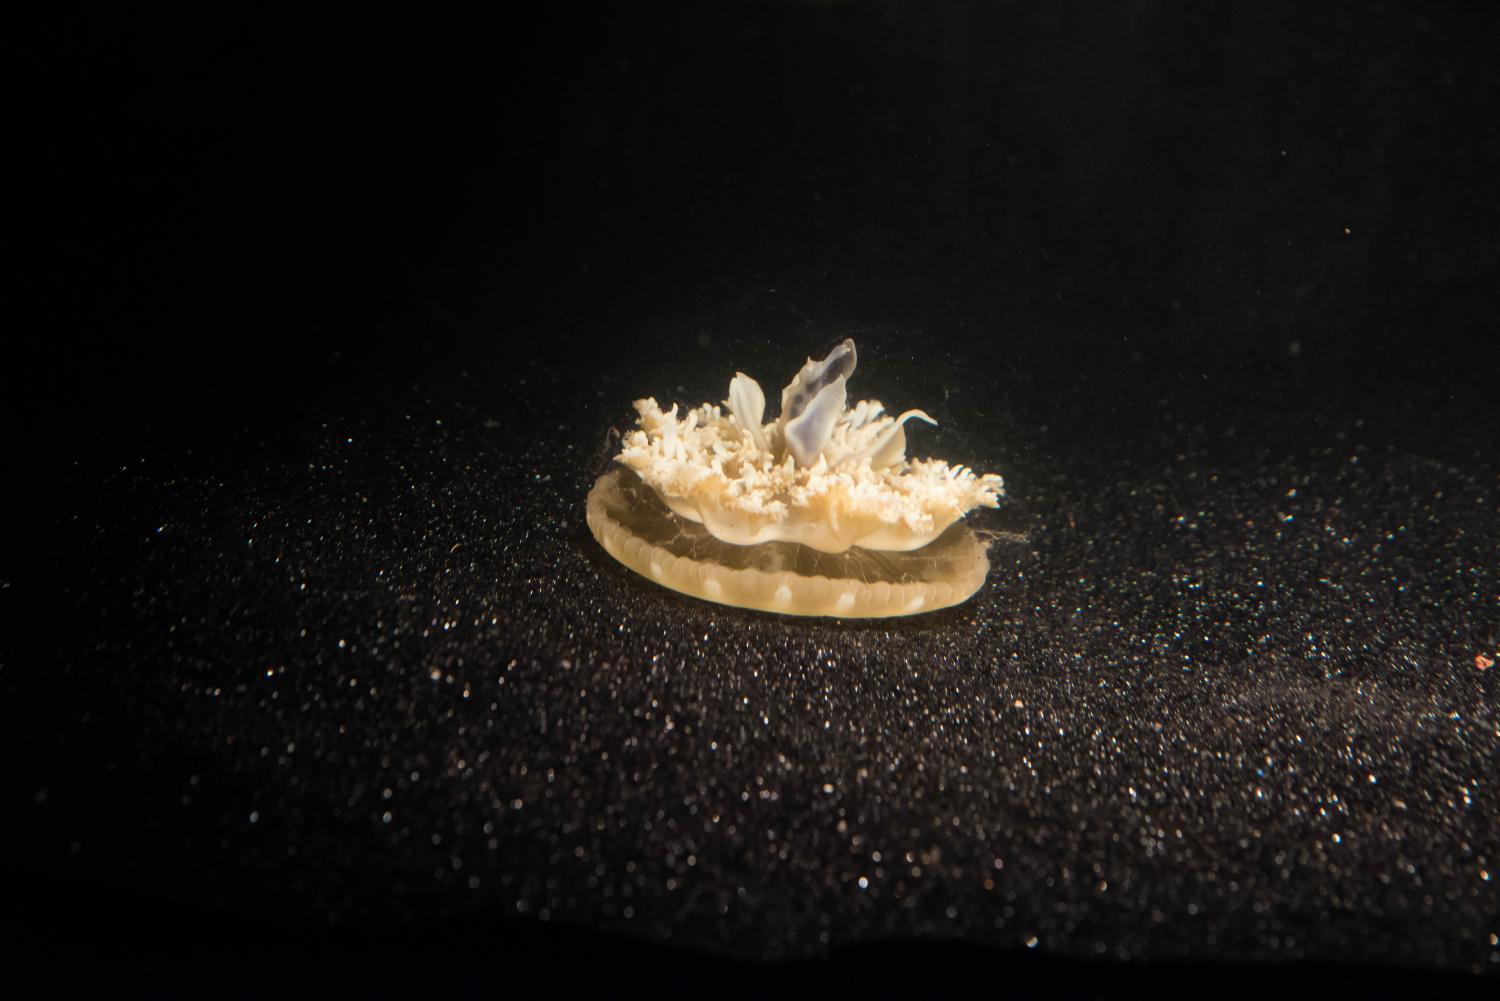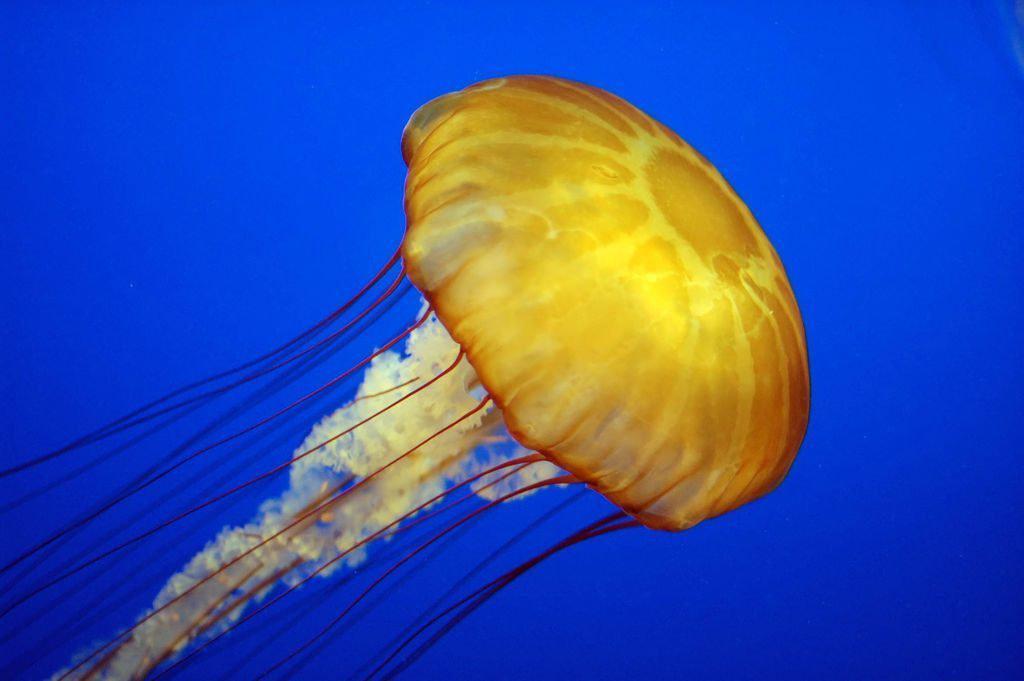The first image is the image on the left, the second image is the image on the right. Examine the images to the left and right. Is the description "One image shows a single upside-down beige jellyfish with short tentacles extending upward from a saucer-shaped 'cap', and the other image shows a glowing yellowish jellyfish with long stringy tentacles trailing down from a dome 'cap'." accurate? Answer yes or no. Yes. 